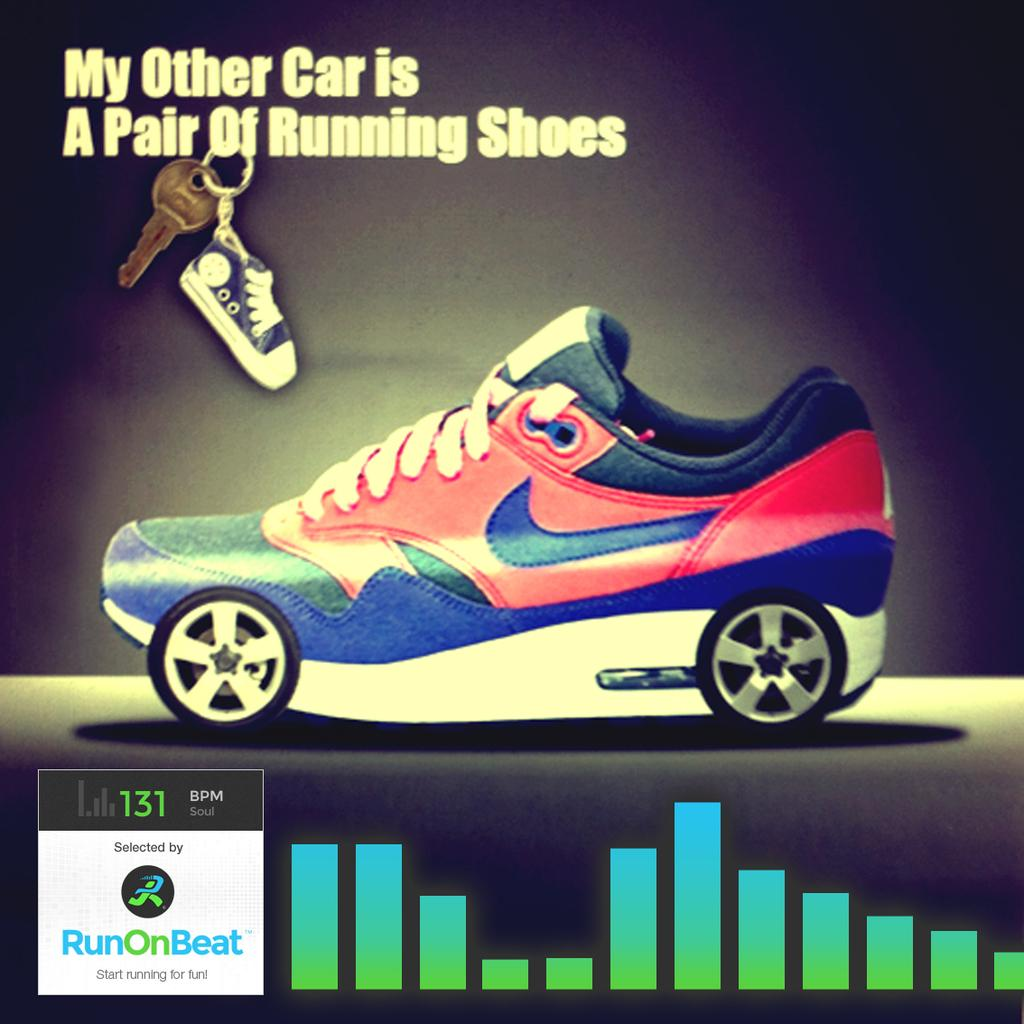What is the main subject of the poster in the image? The main subject of the poster in the image is a shoe. What is located at the top of the shoe on the poster? There is a key and a toy shoe at the top of the shoe on the poster. What else can be seen on the poster besides the shoe? There is text written on the poster and a logo. What type of wheel is visible on the toy shoe in the image? There is no wheel visible on the toy shoe in the image; it is a toy shoe placed at the top of the shoe on the poster. 